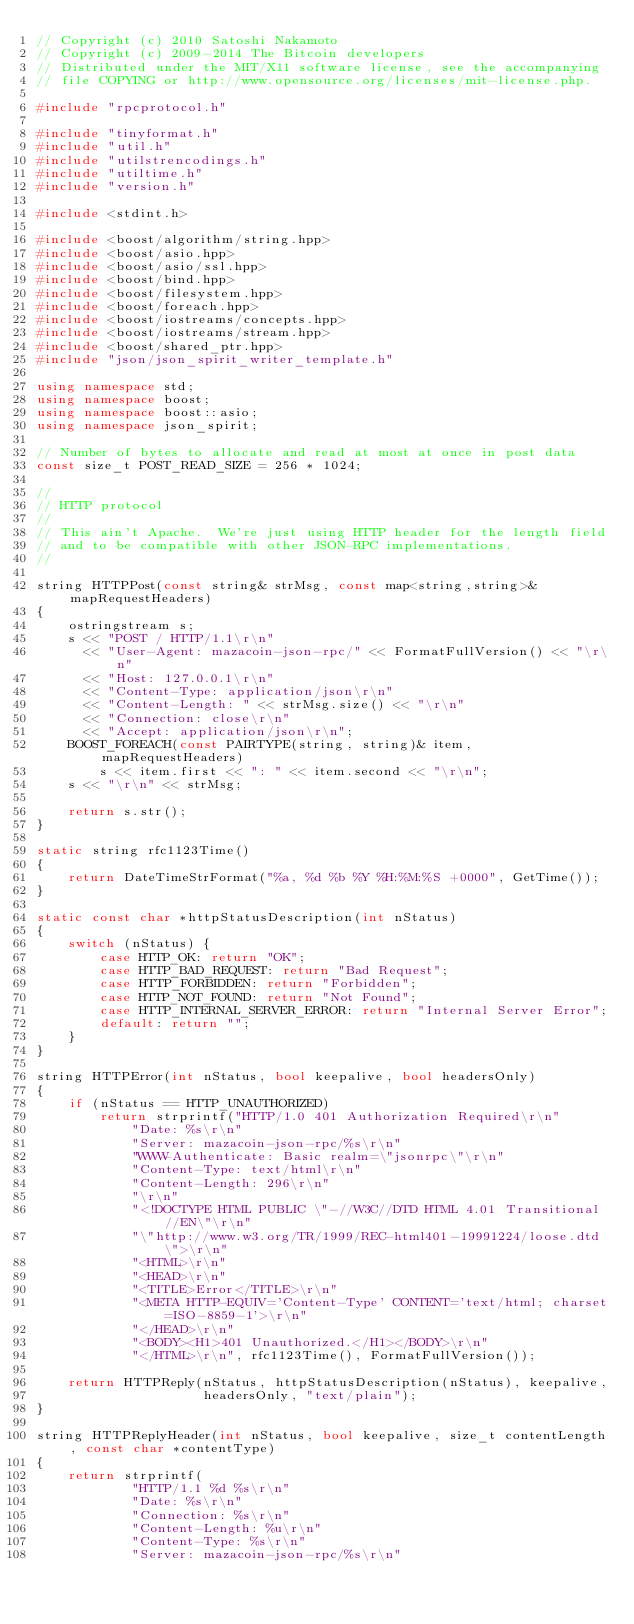Convert code to text. <code><loc_0><loc_0><loc_500><loc_500><_C++_>// Copyright (c) 2010 Satoshi Nakamoto
// Copyright (c) 2009-2014 The Bitcoin developers
// Distributed under the MIT/X11 software license, see the accompanying
// file COPYING or http://www.opensource.org/licenses/mit-license.php.

#include "rpcprotocol.h"

#include "tinyformat.h"
#include "util.h"
#include "utilstrencodings.h"
#include "utiltime.h"
#include "version.h"

#include <stdint.h>

#include <boost/algorithm/string.hpp>
#include <boost/asio.hpp>
#include <boost/asio/ssl.hpp>
#include <boost/bind.hpp>
#include <boost/filesystem.hpp>
#include <boost/foreach.hpp>
#include <boost/iostreams/concepts.hpp>
#include <boost/iostreams/stream.hpp>
#include <boost/shared_ptr.hpp>
#include "json/json_spirit_writer_template.h"

using namespace std;
using namespace boost;
using namespace boost::asio;
using namespace json_spirit;

// Number of bytes to allocate and read at most at once in post data
const size_t POST_READ_SIZE = 256 * 1024;

//
// HTTP protocol
//
// This ain't Apache.  We're just using HTTP header for the length field
// and to be compatible with other JSON-RPC implementations.
//

string HTTPPost(const string& strMsg, const map<string,string>& mapRequestHeaders)
{
    ostringstream s;
    s << "POST / HTTP/1.1\r\n"
      << "User-Agent: mazacoin-json-rpc/" << FormatFullVersion() << "\r\n"
      << "Host: 127.0.0.1\r\n"
      << "Content-Type: application/json\r\n"
      << "Content-Length: " << strMsg.size() << "\r\n"
      << "Connection: close\r\n"
      << "Accept: application/json\r\n";
    BOOST_FOREACH(const PAIRTYPE(string, string)& item, mapRequestHeaders)
        s << item.first << ": " << item.second << "\r\n";
    s << "\r\n" << strMsg;

    return s.str();
}

static string rfc1123Time()
{
    return DateTimeStrFormat("%a, %d %b %Y %H:%M:%S +0000", GetTime());
}

static const char *httpStatusDescription(int nStatus)
{
    switch (nStatus) {
        case HTTP_OK: return "OK";
        case HTTP_BAD_REQUEST: return "Bad Request";
        case HTTP_FORBIDDEN: return "Forbidden";
        case HTTP_NOT_FOUND: return "Not Found";
        case HTTP_INTERNAL_SERVER_ERROR: return "Internal Server Error";
        default: return "";
    }
}

string HTTPError(int nStatus, bool keepalive, bool headersOnly)
{
    if (nStatus == HTTP_UNAUTHORIZED)
        return strprintf("HTTP/1.0 401 Authorization Required\r\n"
            "Date: %s\r\n"
            "Server: mazacoin-json-rpc/%s\r\n"
            "WWW-Authenticate: Basic realm=\"jsonrpc\"\r\n"
            "Content-Type: text/html\r\n"
            "Content-Length: 296\r\n"
            "\r\n"
            "<!DOCTYPE HTML PUBLIC \"-//W3C//DTD HTML 4.01 Transitional//EN\"\r\n"
            "\"http://www.w3.org/TR/1999/REC-html401-19991224/loose.dtd\">\r\n"
            "<HTML>\r\n"
            "<HEAD>\r\n"
            "<TITLE>Error</TITLE>\r\n"
            "<META HTTP-EQUIV='Content-Type' CONTENT='text/html; charset=ISO-8859-1'>\r\n"
            "</HEAD>\r\n"
            "<BODY><H1>401 Unauthorized.</H1></BODY>\r\n"
            "</HTML>\r\n", rfc1123Time(), FormatFullVersion());

    return HTTPReply(nStatus, httpStatusDescription(nStatus), keepalive,
                     headersOnly, "text/plain");
}

string HTTPReplyHeader(int nStatus, bool keepalive, size_t contentLength, const char *contentType)
{
    return strprintf(
            "HTTP/1.1 %d %s\r\n"
            "Date: %s\r\n"
            "Connection: %s\r\n"
            "Content-Length: %u\r\n"
            "Content-Type: %s\r\n"
            "Server: mazacoin-json-rpc/%s\r\n"</code> 